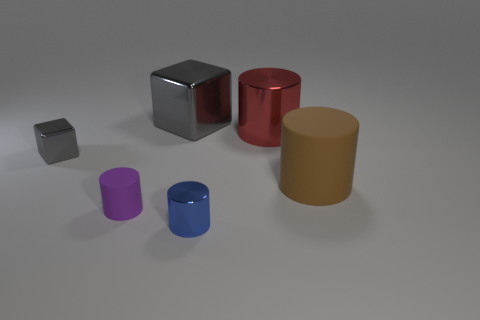There is a metal object that is on the left side of the tiny purple rubber cylinder; is it the same color as the large shiny object that is left of the small blue cylinder?
Ensure brevity in your answer.  Yes. There is a gray object that is right of the tiny shiny object that is behind the large brown matte object; how many big red metallic things are in front of it?
Your response must be concise. 1. Is the number of large blocks that are behind the small purple thing greater than the number of blue cylinders that are on the left side of the big metallic block?
Your answer should be compact. Yes. How many large red objects are the same shape as the big gray shiny object?
Your answer should be very brief. 0. What number of things are either cylinders that are on the left side of the red metallic cylinder or big cylinders on the left side of the brown rubber thing?
Provide a short and direct response. 3. What material is the small cylinder that is to the left of the block that is right of the gray shiny block that is in front of the large block made of?
Your response must be concise. Rubber. Does the metallic thing behind the large red thing have the same color as the big rubber thing?
Your answer should be compact. No. What is the material of the big object that is in front of the large gray metallic thing and behind the large brown rubber cylinder?
Ensure brevity in your answer.  Metal. Are there any purple cylinders of the same size as the purple thing?
Give a very brief answer. No. What number of cylinders are there?
Offer a terse response. 4. 